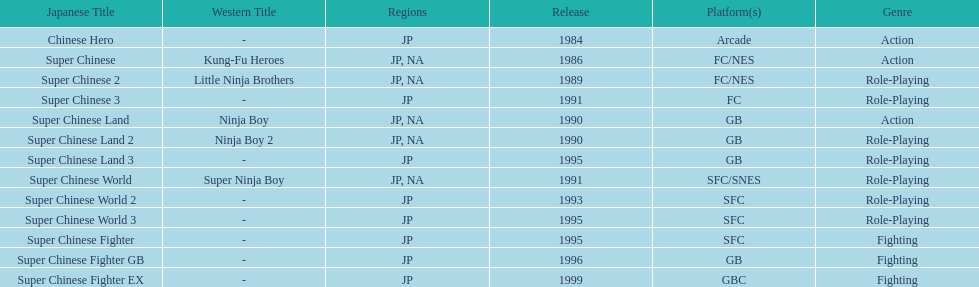In north america, how many action games have been made available? 2. 